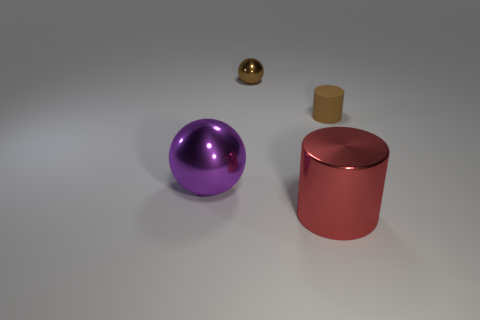Add 4 tiny brown metal balls. How many objects exist? 8 Add 1 purple metal spheres. How many purple metal spheres exist? 2 Subtract 0 blue balls. How many objects are left? 4 Subtract all tiny brown cylinders. Subtract all big green spheres. How many objects are left? 3 Add 3 large red objects. How many large red objects are left? 4 